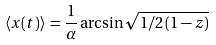Convert formula to latex. <formula><loc_0><loc_0><loc_500><loc_500>\langle x ( t ) \rangle \, = \frac { 1 } { \alpha } \arcsin \sqrt { 1 / 2 \, ( 1 - z ) }</formula> 